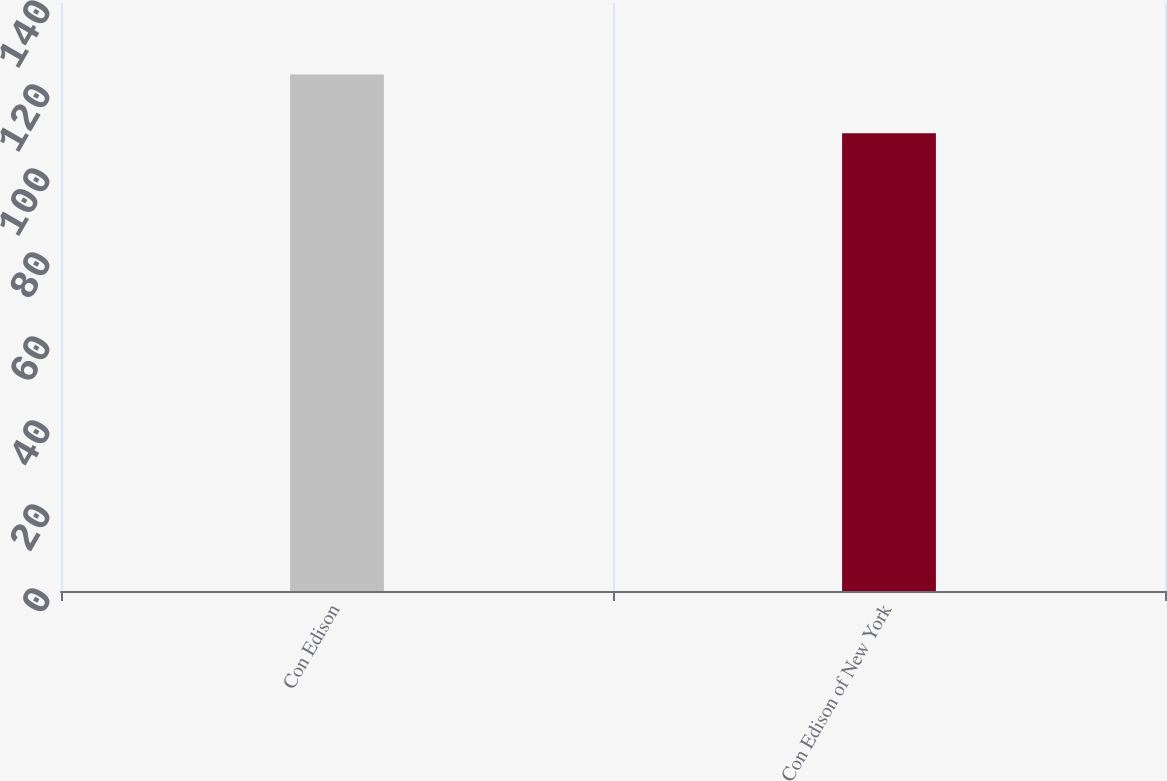Convert chart to OTSL. <chart><loc_0><loc_0><loc_500><loc_500><bar_chart><fcel>Con Edison<fcel>Con Edison of New York<nl><fcel>123<fcel>109<nl></chart> 